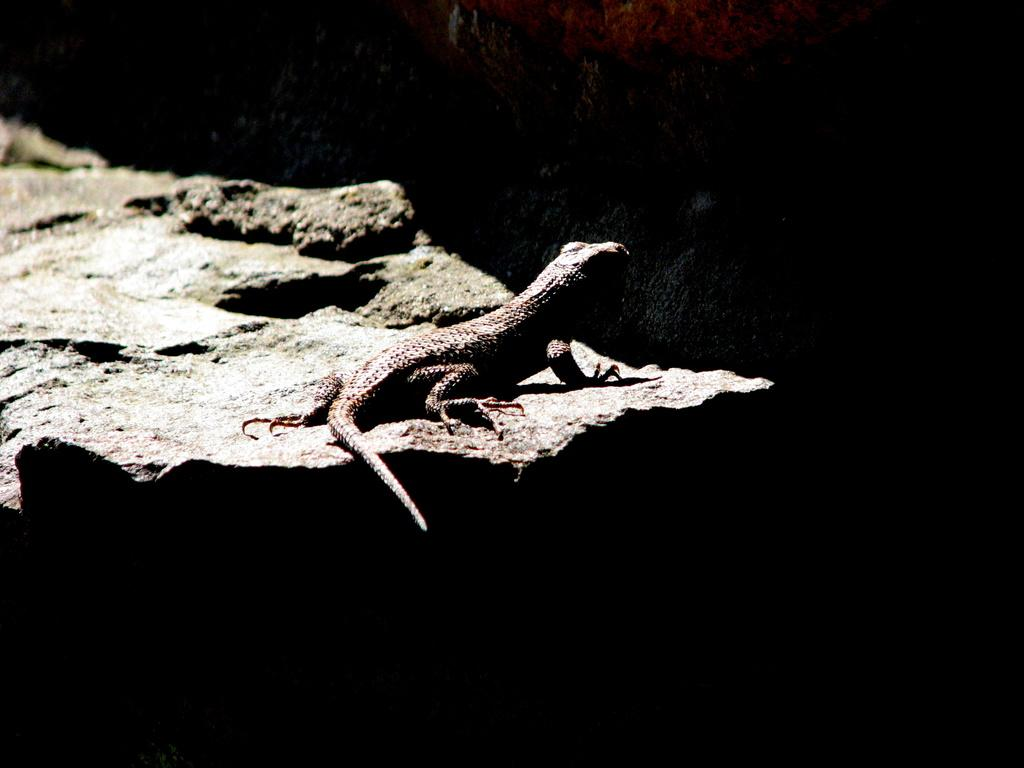What type of animal is in the image? There is a lizard in the image. Where is the lizard located? The lizard is on a rock. What is the color of the background in the image? The background of the image is dark in color. What type of bear can be seen in the crib in the image? There is no bear or crib present in the image; it features a lizard on a rock with a dark background. 